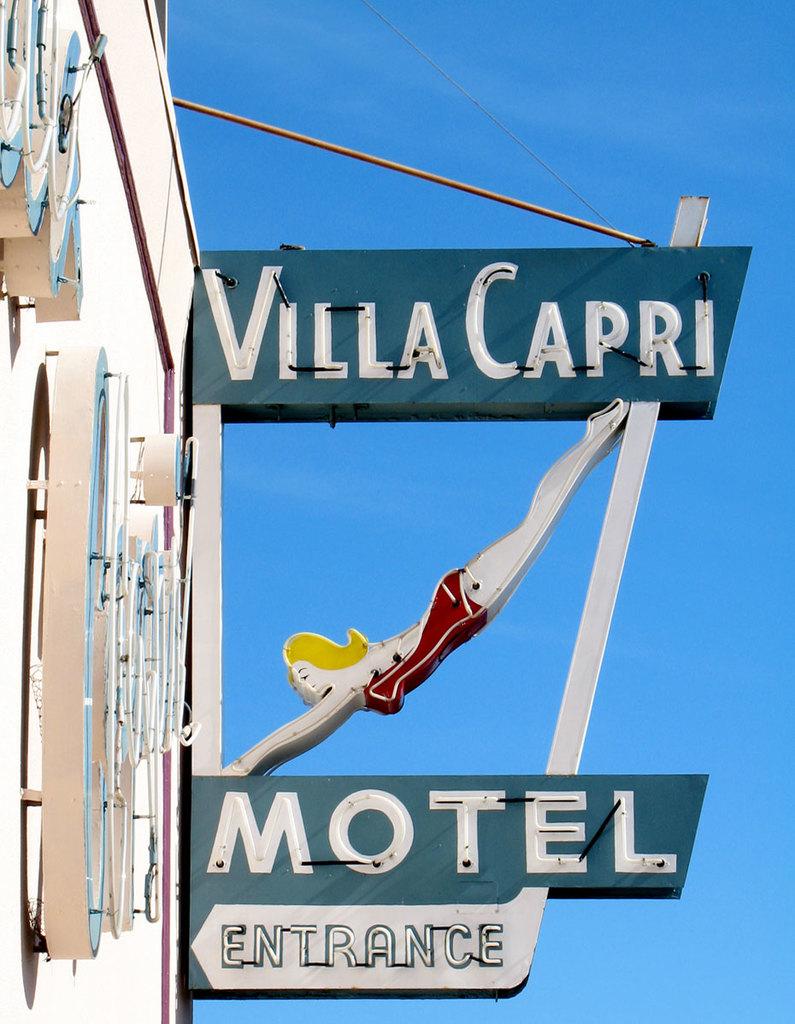What does the sign point an entrance to?
Ensure brevity in your answer.  Motel. What is the name of the motel?
Offer a terse response. Villa capri. 